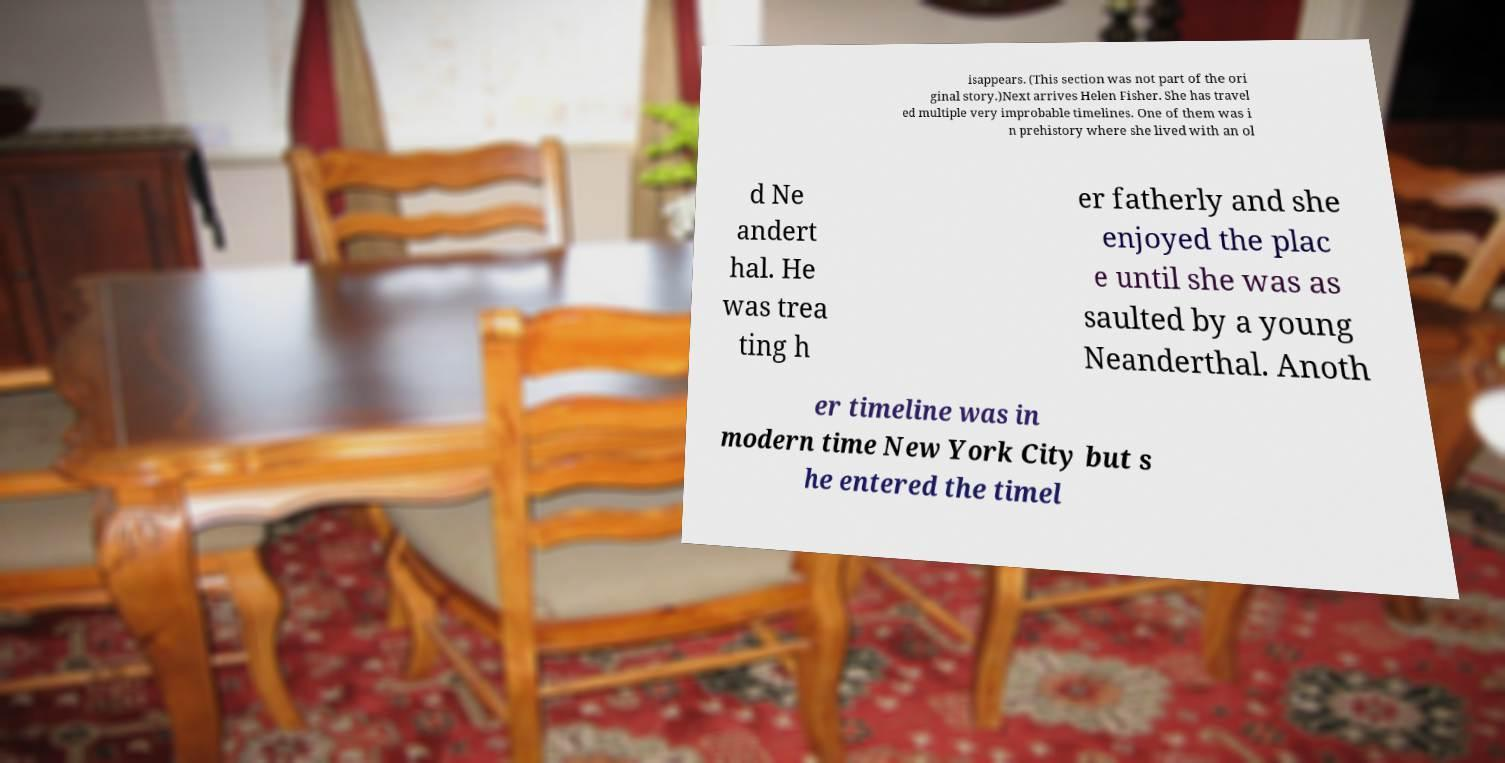I need the written content from this picture converted into text. Can you do that? isappears. (This section was not part of the ori ginal story.)Next arrives Helen Fisher. She has travel ed multiple very improbable timelines. One of them was i n prehistory where she lived with an ol d Ne andert hal. He was trea ting h er fatherly and she enjoyed the plac e until she was as saulted by a young Neanderthal. Anoth er timeline was in modern time New York City but s he entered the timel 